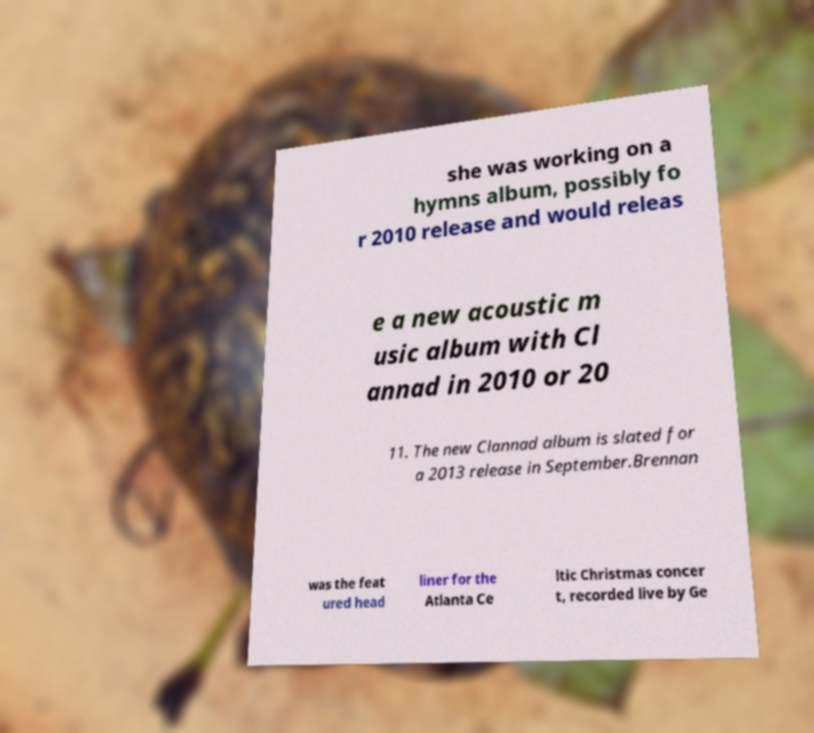I need the written content from this picture converted into text. Can you do that? she was working on a hymns album, possibly fo r 2010 release and would releas e a new acoustic m usic album with Cl annad in 2010 or 20 11. The new Clannad album is slated for a 2013 release in September.Brennan was the feat ured head liner for the Atlanta Ce ltic Christmas concer t, recorded live by Ge 